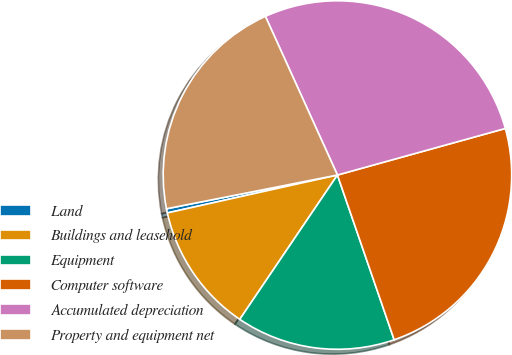Convert chart to OTSL. <chart><loc_0><loc_0><loc_500><loc_500><pie_chart><fcel>Land<fcel>Buildings and leasehold<fcel>Equipment<fcel>Computer software<fcel>Accumulated depreciation<fcel>Property and equipment net<nl><fcel>0.39%<fcel>12.04%<fcel>14.75%<fcel>24.03%<fcel>27.48%<fcel>21.32%<nl></chart> 